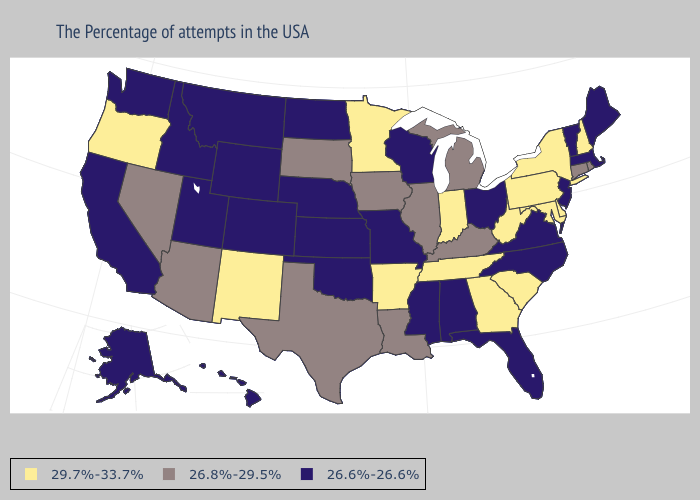Does the first symbol in the legend represent the smallest category?
Keep it brief. No. What is the value of Iowa?
Quick response, please. 26.8%-29.5%. What is the highest value in the Northeast ?
Short answer required. 29.7%-33.7%. Does Virginia have a lower value than Arizona?
Give a very brief answer. Yes. What is the highest value in states that border Arkansas?
Quick response, please. 29.7%-33.7%. What is the value of Mississippi?
Give a very brief answer. 26.6%-26.6%. What is the value of Alabama?
Be succinct. 26.6%-26.6%. Does Kansas have the lowest value in the MidWest?
Be succinct. Yes. What is the value of New York?
Write a very short answer. 29.7%-33.7%. Among the states that border Delaware , which have the highest value?
Short answer required. Maryland, Pennsylvania. Name the states that have a value in the range 29.7%-33.7%?
Quick response, please. New Hampshire, New York, Delaware, Maryland, Pennsylvania, South Carolina, West Virginia, Georgia, Indiana, Tennessee, Arkansas, Minnesota, New Mexico, Oregon. Name the states that have a value in the range 26.6%-26.6%?
Keep it brief. Maine, Massachusetts, Vermont, New Jersey, Virginia, North Carolina, Ohio, Florida, Alabama, Wisconsin, Mississippi, Missouri, Kansas, Nebraska, Oklahoma, North Dakota, Wyoming, Colorado, Utah, Montana, Idaho, California, Washington, Alaska, Hawaii. What is the value of Michigan?
Keep it brief. 26.8%-29.5%. Name the states that have a value in the range 29.7%-33.7%?
Give a very brief answer. New Hampshire, New York, Delaware, Maryland, Pennsylvania, South Carolina, West Virginia, Georgia, Indiana, Tennessee, Arkansas, Minnesota, New Mexico, Oregon. Name the states that have a value in the range 26.8%-29.5%?
Answer briefly. Rhode Island, Connecticut, Michigan, Kentucky, Illinois, Louisiana, Iowa, Texas, South Dakota, Arizona, Nevada. 